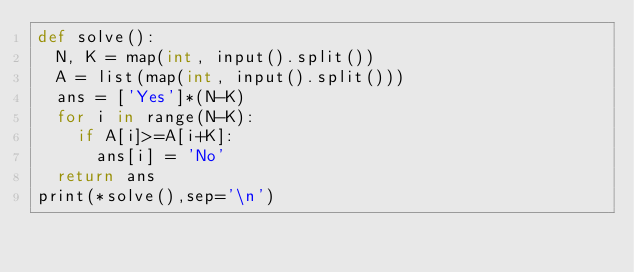Convert code to text. <code><loc_0><loc_0><loc_500><loc_500><_Cython_>def solve():
  N, K = map(int, input().split())
  A = list(map(int, input().split()))
  ans = ['Yes']*(N-K)
  for i in range(N-K):
    if A[i]>=A[i+K]:
      ans[i] = 'No'
  return ans
print(*solve(),sep='\n')
</code> 